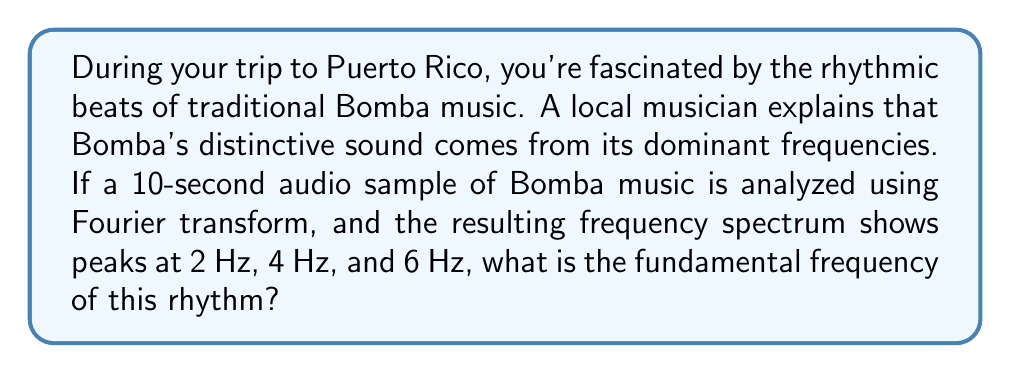Can you solve this math problem? To solve this problem, we need to understand a few key concepts:

1. Fourier transform: This mathematical technique decomposes a signal into its constituent frequencies.

2. Fundamental frequency: The lowest frequency in a periodic waveform, often denoted as $f_0$.

3. Harmonic frequencies: Integer multiples of the fundamental frequency.

In this case, we observe peaks at 2 Hz, 4 Hz, and 6 Hz. Let's analyze these frequencies:

$$\begin{align}
2 \text{ Hz} &= 1 \times 2 \text{ Hz} \\
4 \text{ Hz} &= 2 \times 2 \text{ Hz} \\
6 \text{ Hz} &= 3 \times 2 \text{ Hz}
\end{align}$$

We can see that these frequencies form a harmonic series, where each frequency is an integer multiple of 2 Hz. Therefore, 2 Hz is the fundamental frequency, as it's the greatest common factor of all the observed frequencies.

In musical terms, this fundamental frequency of 2 Hz corresponds to a rhythm with a period of:

$$T = \frac{1}{f_0} = \frac{1}{2 \text{ Hz}} = 0.5 \text{ seconds}$$

This means the basic rhythmic unit repeats every half second, which is consistent with the lively, up-tempo nature of Bomba music.
Answer: The fundamental frequency of the Bomba rhythm is 2 Hz. 